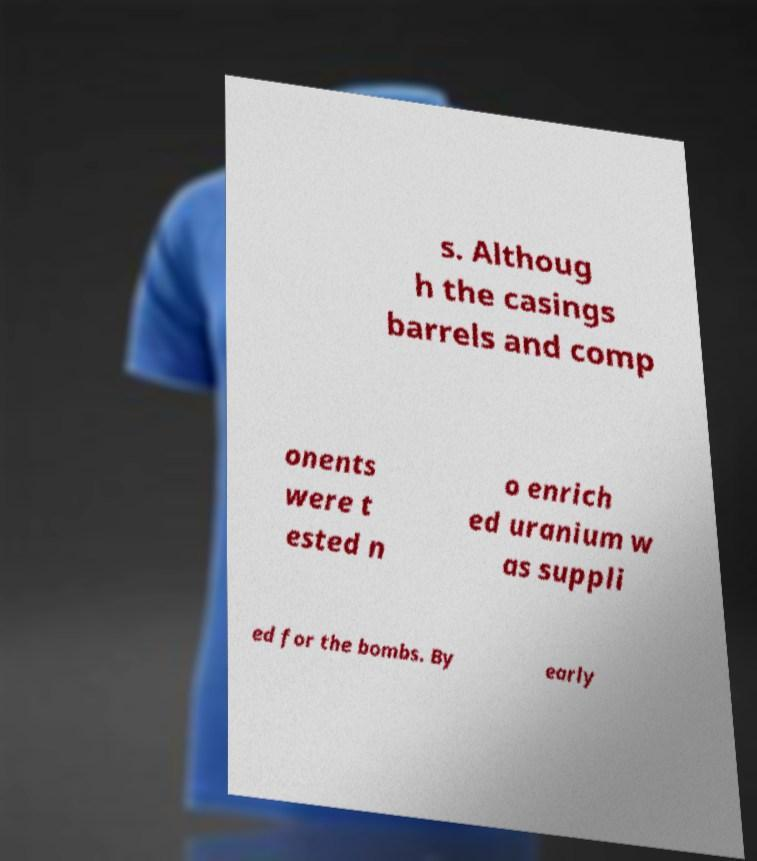Could you assist in decoding the text presented in this image and type it out clearly? s. Althoug h the casings barrels and comp onents were t ested n o enrich ed uranium w as suppli ed for the bombs. By early 